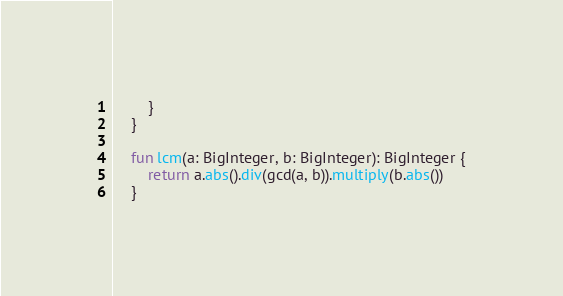Convert code to text. <code><loc_0><loc_0><loc_500><loc_500><_Kotlin_>        }
    }

    fun lcm(a: BigInteger, b: BigInteger): BigInteger {
        return a.abs().div(gcd(a, b)).multiply(b.abs())
    }
</code> 